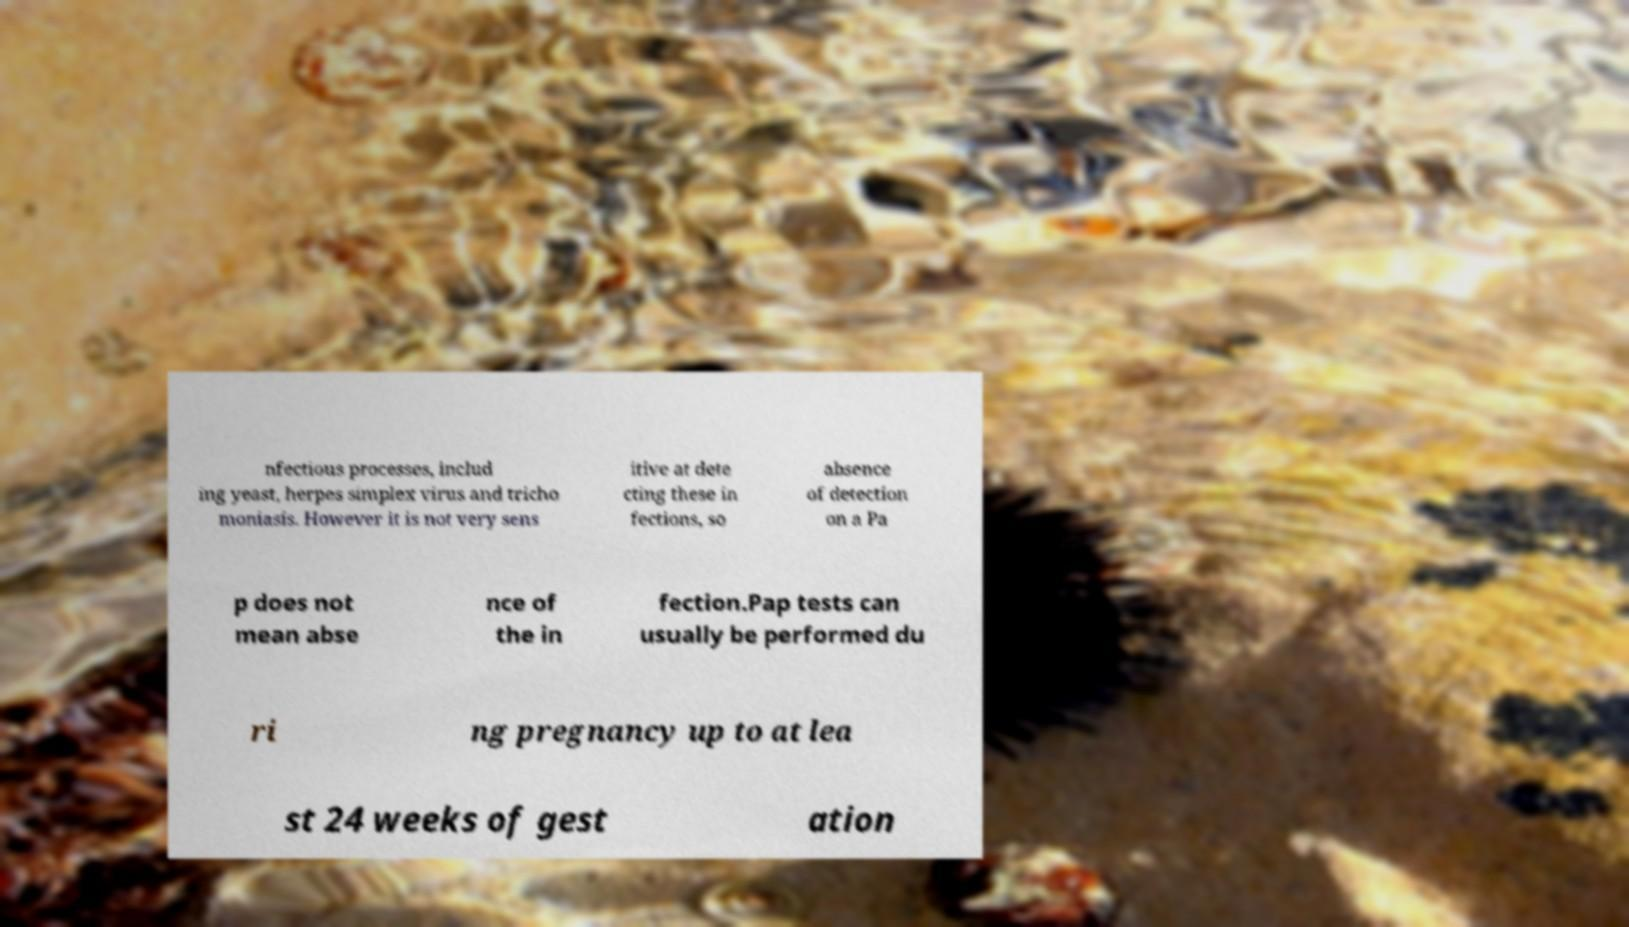Can you read and provide the text displayed in the image?This photo seems to have some interesting text. Can you extract and type it out for me? nfectious processes, includ ing yeast, herpes simplex virus and tricho moniasis. However it is not very sens itive at dete cting these in fections, so absence of detection on a Pa p does not mean abse nce of the in fection.Pap tests can usually be performed du ri ng pregnancy up to at lea st 24 weeks of gest ation 